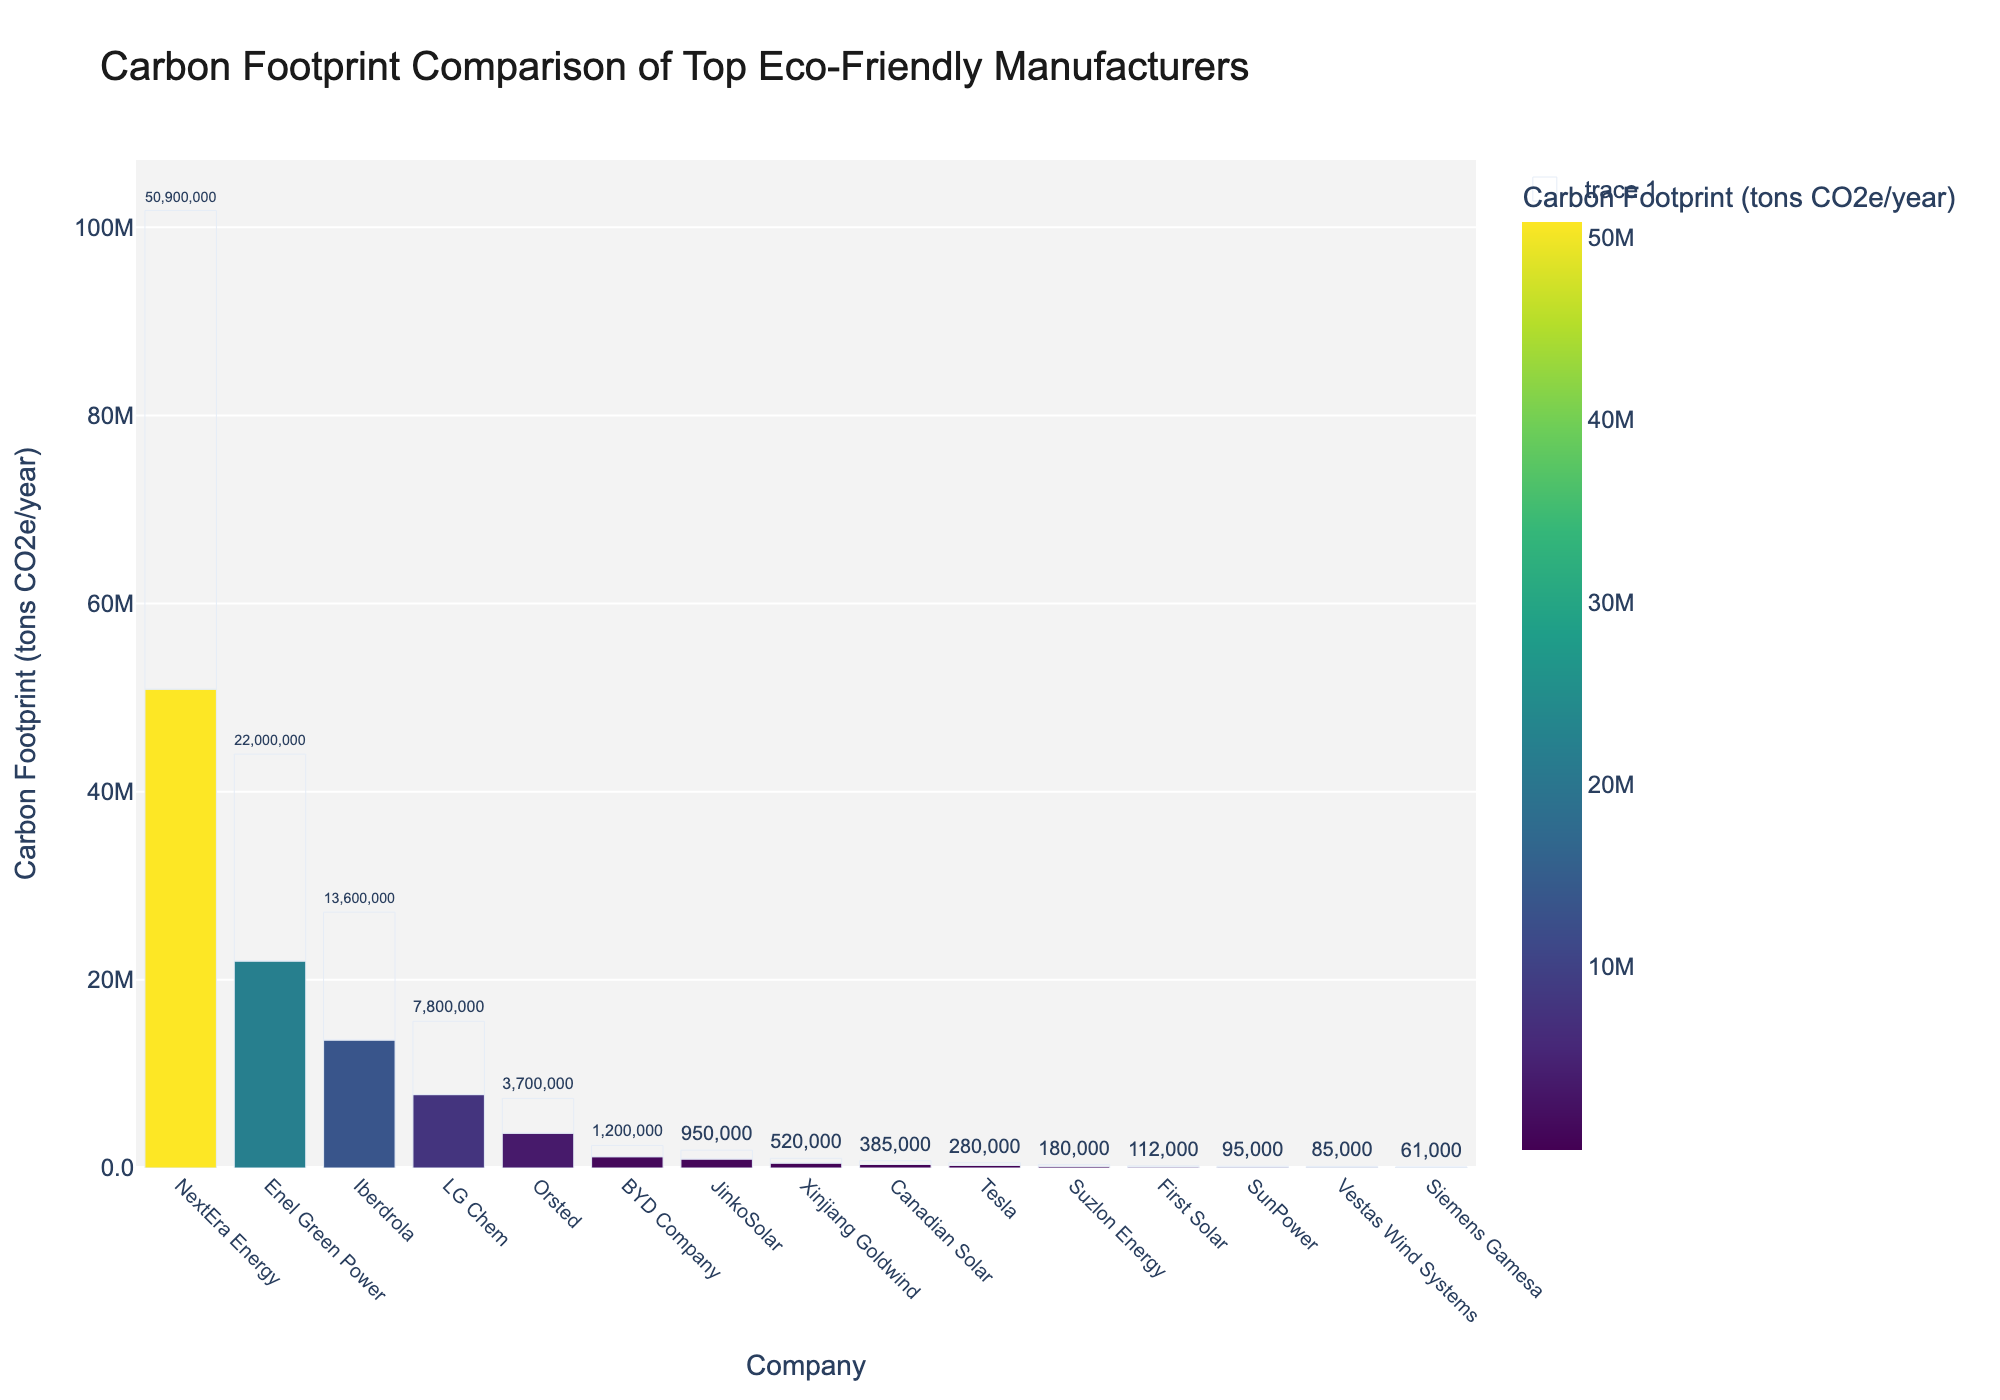Which company has the highest carbon footprint? The company with the highest carbon footprint will have the tallest bar in the chart. By looking at the chart, NextEra Energy has the highest bar, indicating the highest carbon footprint.
Answer: NextEra Energy Which company has the lowest carbon footprint? The company with the lowest carbon footprint will have the shortest bar in the chart. By examining the chart, Siemens Gamesa has the shortest bar, indicating the lowest carbon footprint.
Answer: Siemens Gamesa What is the combined carbon footprint of Orsted and Enel Green Power? To find the combined carbon footprint, sum the values of Orsted and Enel Green Power. From the chart, Orsted has 3,700,000 tons CO2e/year and Enel Green Power has 22,000,000 tons CO2e/year. Their combined carbon footprint is 3,700,000 + 22,000,000 = 25,700,000 tons CO2e/year.
Answer: 25,700,000 Which companies have a carbon footprint less than 500,000 tons CO2e/year? To find the companies with a carbon footprint less than 500,000 tons CO2e/year, look for bars shorter than the 500,000 mark. The companies are Tesla, Vestas Wind Systems, First Solar, Siemens Gamesa, SunPower, and Suzlon Energy.
Answer: Tesla, Vestas Wind Systems, First Solar, Siemens Gamesa, SunPower, Suzlon Energy What is the difference in carbon footprint between Tesla and BYD Company? To find the difference, subtract Tesla's carbon footprint from BYD Company's. Tesla has 280,000 tons CO2e/year and BYD Company has 1,200,000 tons CO2e/year. The difference is 1,200,000 - 280,000 = 920,000 tons CO2e/year.
Answer: 920,000 Which company has a higher carbon footprint, LG Chem or JinkoSolar? Compare the height of the bars for LG Chem and JinkoSolar. LG Chem has a higher carbon footprint with 7,800,000 tons CO2e/year compared to JinkoSolar with 950,000 tons CO2e/year.
Answer: LG Chem What is the average carbon footprint of the companies with a carbon footprint above 10,000,000 tons CO2e/year? Identify the companies with a carbon footprint above 10,000,000 tons CO2e/year. They are Iberdrola, NextEra Energy, and Enel Green Power. Sum their carbon footprints: 13,600,000 + 50,900,000 + 22,000,000 = 86,500,000. Divide by 3 (number of companies): 86,500,000 / 3 = 28,833,333.33 tons CO2e/year.
Answer: 28,833,333.33 What is the total carbon footprint of all companies combined? Add up the carbon footprints of all the companies. The total is the sum of each value provided: 280,000 + 85,000 + 112,000 + 3,700,000 + 61,000 + 385,000 + 95,000 + 13,600,000 + 50,900,000 + 22,000,000 + 7,800,000 + 1,200,000 + 520,000 + 950,000 + 180,000 = 101,868,000 tons CO2e/year.
Answer: 101,868,000 Which company has the second lowest carbon footprint? Look for the second shortest bar in the chart. After Siemens Gamesa, which has the lowest, Vestas Wind Systems has the next shortest bar, indicating the second lowest carbon footprint.
Answer: Vestas Wind Systems How many companies have a carbon footprint greater than 1,000,000 tons CO2e/year? Identify and count the companies with bars taller than the 1,000,000 mark. The companies are BYD Company, LG Chem, Iberdrola, NextEra Energy, and Enel Green Power. There are 5 such companies.
Answer: 5 